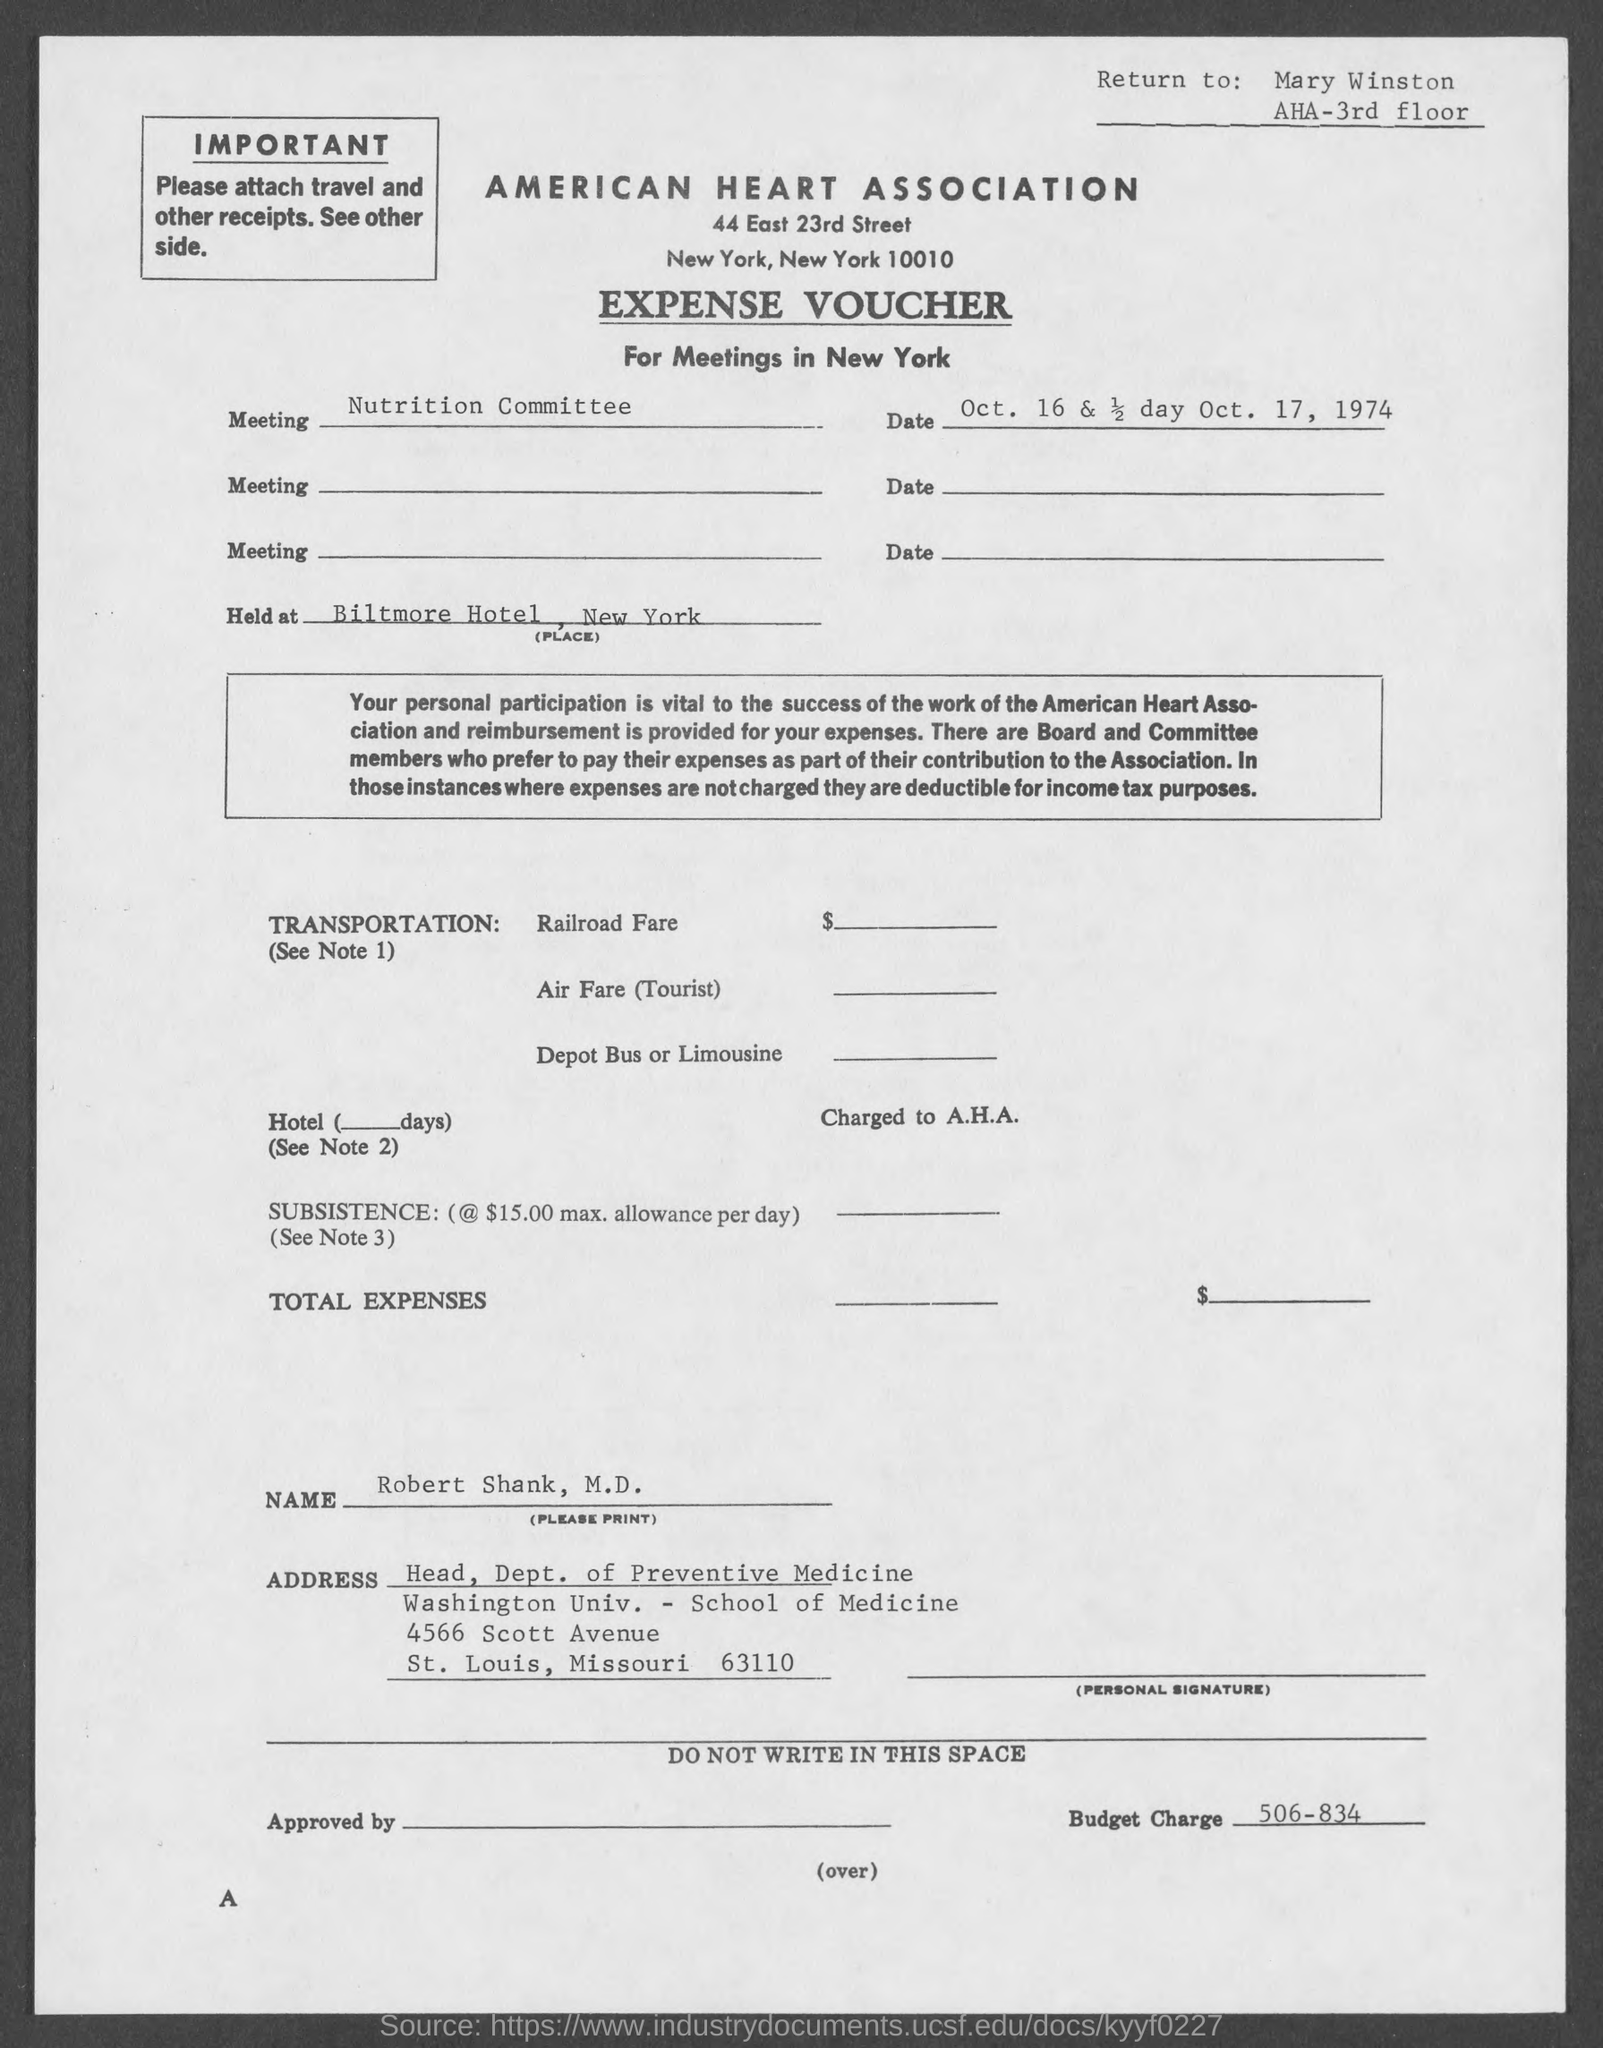What is the meeting?
Make the answer very short. Nutrition Committee. Where is it held at?
Provide a short and direct response. Biltmore Hotel , New York. What is the Name?
Offer a very short reply. Robert Shank, M.D. What is the budget charge?
Your answer should be very brief. 506-834. 